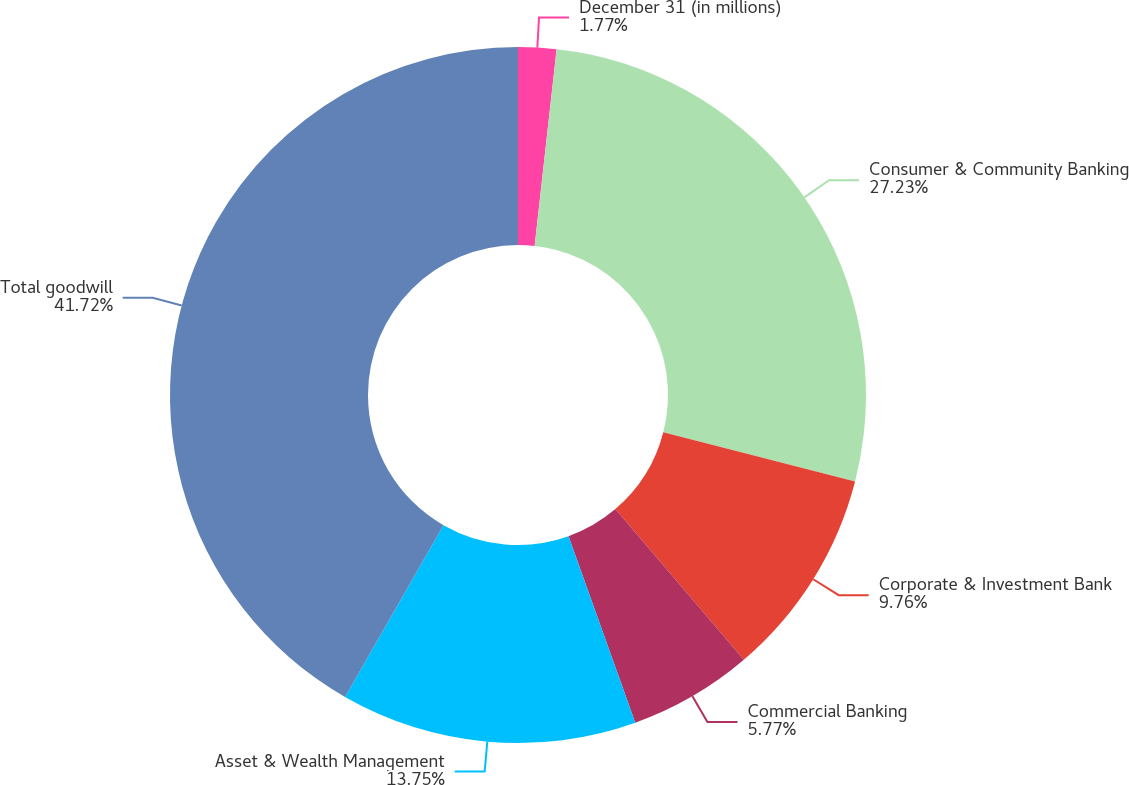<chart> <loc_0><loc_0><loc_500><loc_500><pie_chart><fcel>December 31 (in millions)<fcel>Consumer & Community Banking<fcel>Corporate & Investment Bank<fcel>Commercial Banking<fcel>Asset & Wealth Management<fcel>Total goodwill<nl><fcel>1.77%<fcel>27.23%<fcel>9.76%<fcel>5.77%<fcel>13.75%<fcel>41.72%<nl></chart> 